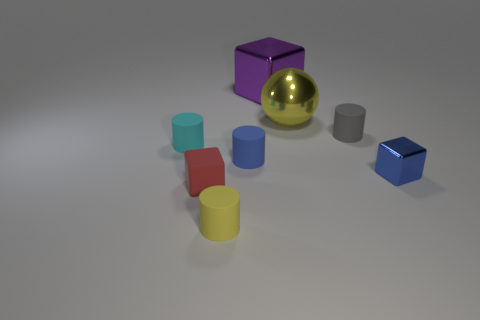What number of blue metal cubes are left of the yellow object behind the tiny cylinder that is on the left side of the small red cube?
Offer a very short reply. 0. Is there any other thing that is the same shape as the big yellow thing?
Your response must be concise. No. What number of things are either blue rubber objects or large cyan shiny blocks?
Your answer should be compact. 1. There is a yellow shiny object; is it the same shape as the small rubber thing that is to the left of the small red rubber cube?
Offer a very short reply. No. There is a large yellow thing that is to the right of the cyan rubber thing; what shape is it?
Give a very brief answer. Sphere. Does the purple object have the same shape as the small gray thing?
Provide a succinct answer. No. What is the size of the blue rubber object that is the same shape as the tiny gray matte thing?
Offer a terse response. Small. There is a block on the right side of the gray matte object; is its size the same as the tiny cyan matte object?
Your answer should be very brief. Yes. There is a rubber thing that is right of the tiny yellow cylinder and on the left side of the purple object; what is its size?
Provide a short and direct response. Small. There is a tiny object that is the same color as the shiny sphere; what is its material?
Keep it short and to the point. Rubber. 